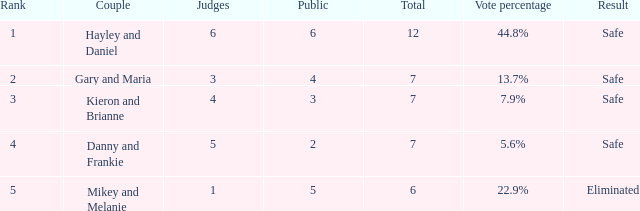What was the maximum rank for the vote percentage of 5.6% 4.0. 